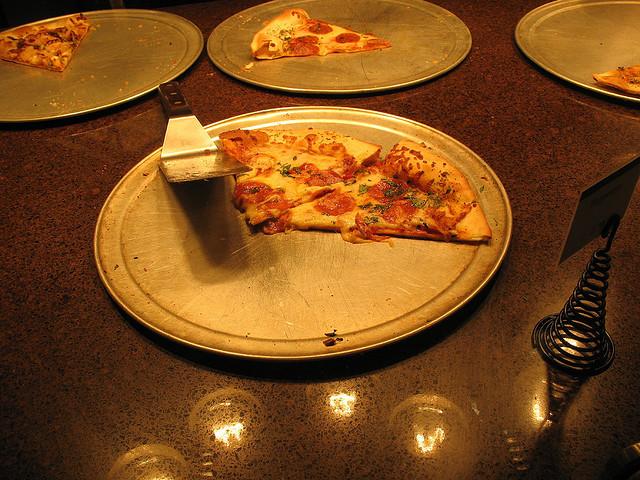What is on the small plate above the pizza?
Be succinct. Pizza. How many pieces of pizza are there?
Quick response, please. 5. What type of utensil is on the tray?
Give a very brief answer. Spatula. What is causing the glare on the table?
Answer briefly. Lights. 